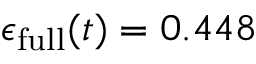<formula> <loc_0><loc_0><loc_500><loc_500>\epsilon _ { f u l l } ( t ) = 0 . 4 4 8</formula> 